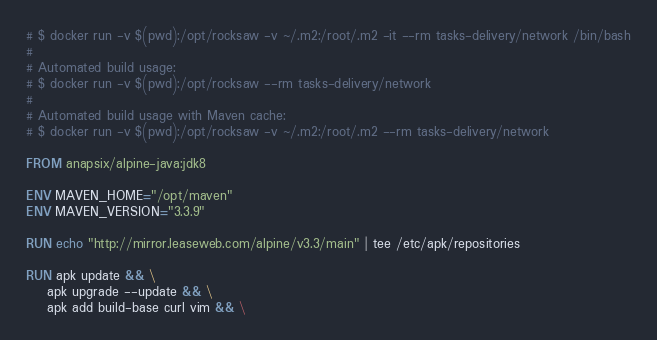Convert code to text. <code><loc_0><loc_0><loc_500><loc_500><_Dockerfile_># $ docker run -v $(pwd):/opt/rocksaw -v ~/.m2:/root/.m2 -it --rm tasks-delivery/network /bin/bash
#
# Automated build usage:
# $ docker run -v $(pwd):/opt/rocksaw --rm tasks-delivery/network
#
# Automated build usage with Maven cache:
# $ docker run -v $(pwd):/opt/rocksaw -v ~/.m2:/root/.m2 --rm tasks-delivery/network

FROM anapsix/alpine-java:jdk8

ENV MAVEN_HOME="/opt/maven"
ENV MAVEN_VERSION="3.3.9"

RUN echo "http://mirror.leaseweb.com/alpine/v3.3/main" | tee /etc/apk/repositories

RUN apk update && \
    apk upgrade --update && \
    apk add build-base curl vim && \</code> 